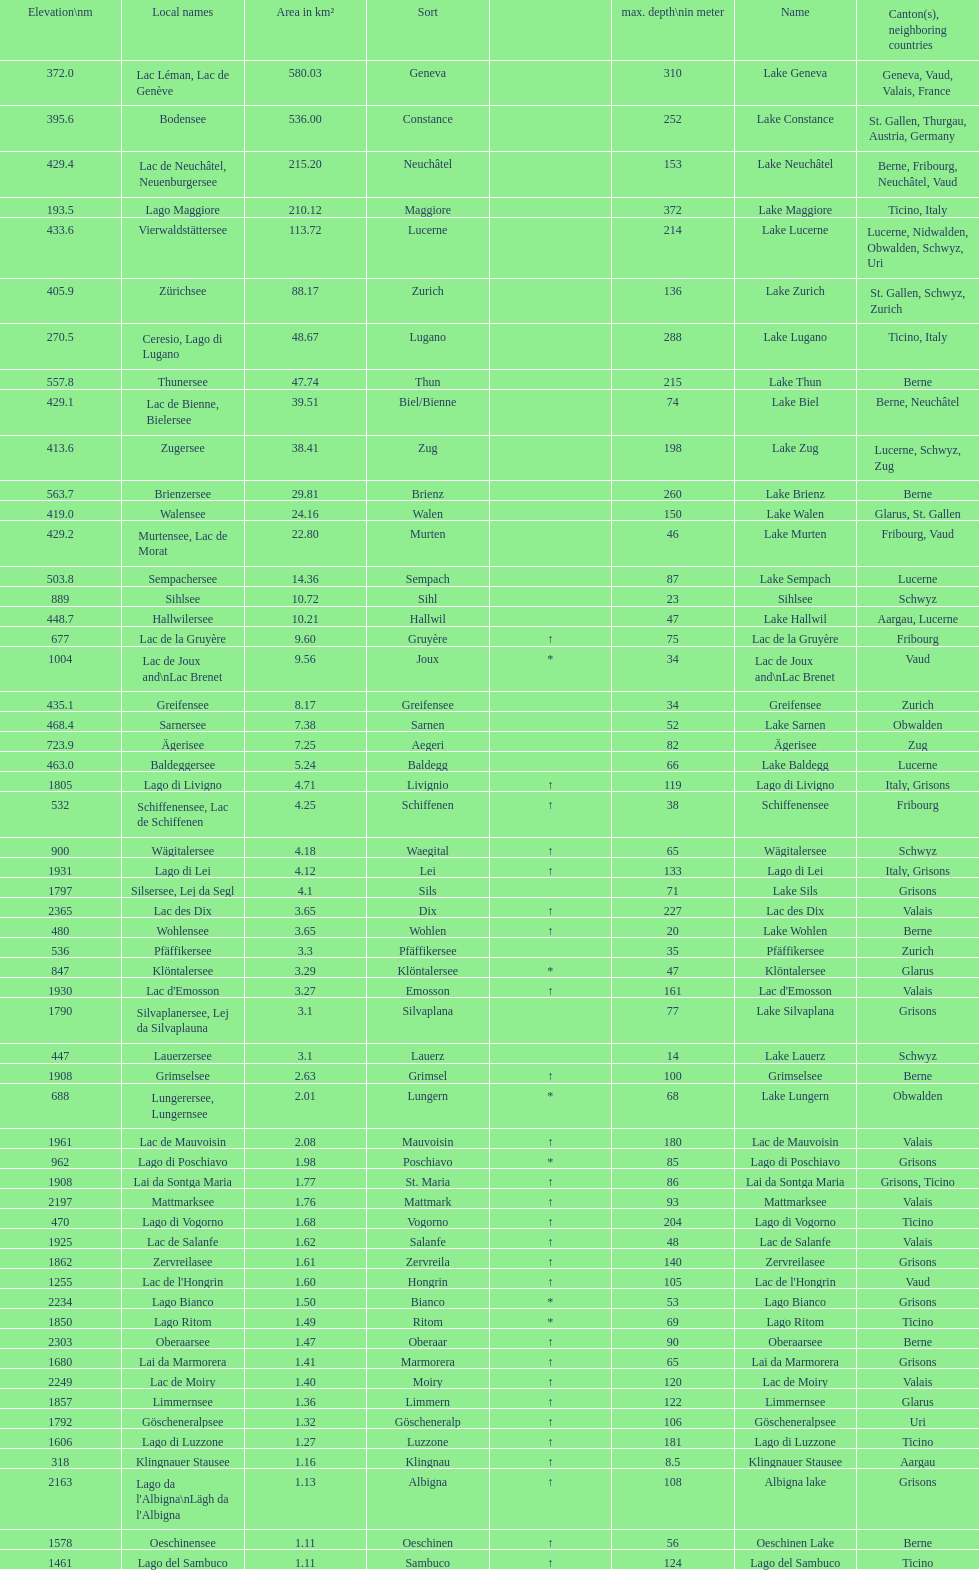Which lake possesses the highest elevation? Lac des Dix. 